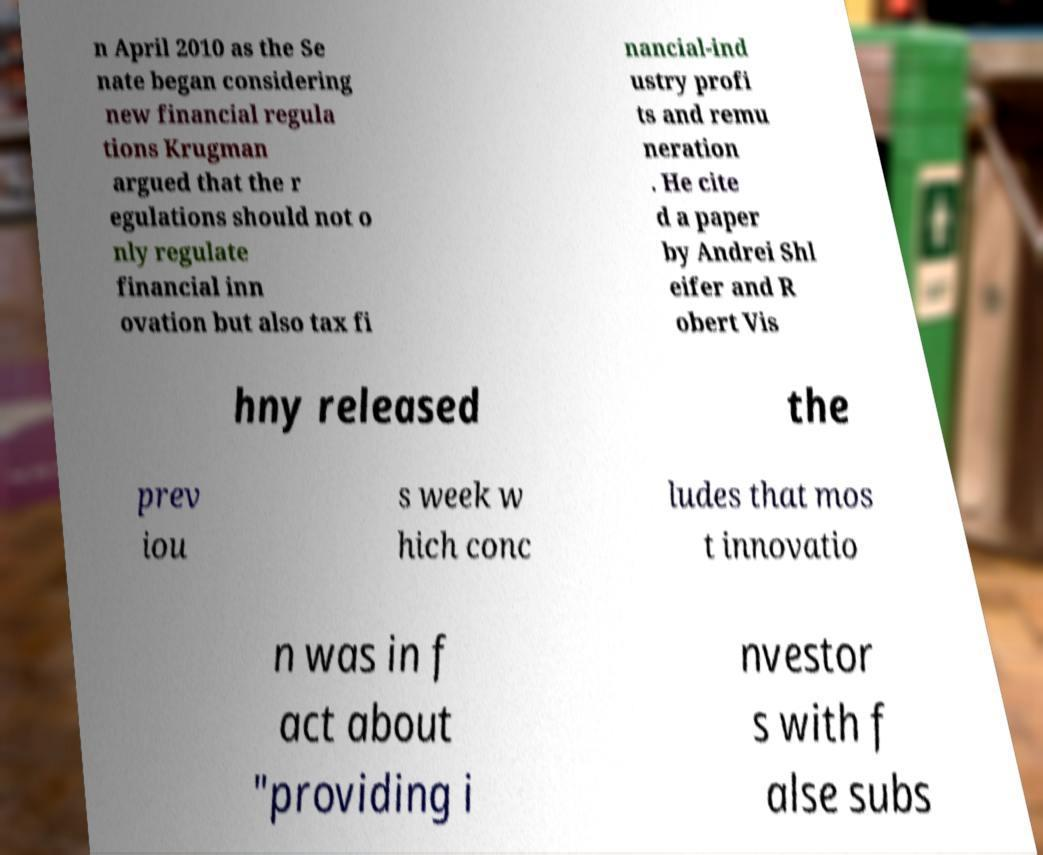Can you read and provide the text displayed in the image?This photo seems to have some interesting text. Can you extract and type it out for me? n April 2010 as the Se nate began considering new financial regula tions Krugman argued that the r egulations should not o nly regulate financial inn ovation but also tax fi nancial-ind ustry profi ts and remu neration . He cite d a paper by Andrei Shl eifer and R obert Vis hny released the prev iou s week w hich conc ludes that mos t innovatio n was in f act about "providing i nvestor s with f alse subs 